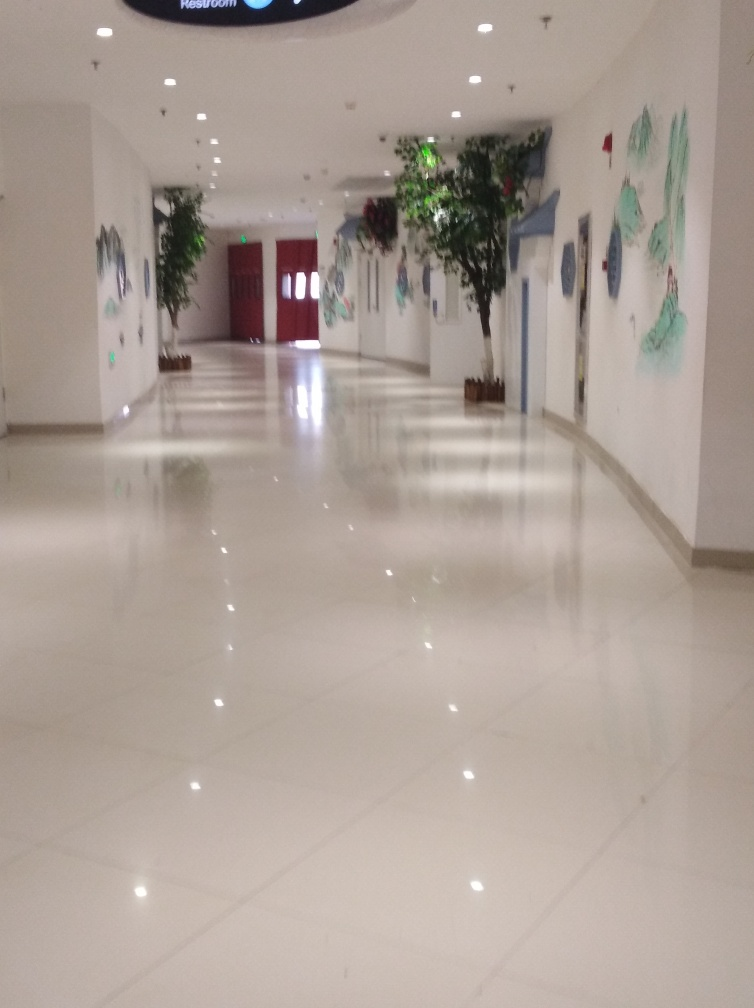Can you comment on the use of lighting in this space? Certainly, the lighting in the space seems thoughtfully designed to create a welcoming ambiance. The ceiling lights provide a soft and even illumination, reflected beautifully on the shiny floor, contributing to the feeling of spaciousness. The strategic placement of lights appears to highlight the wall art without creating harsh shadows, which complements the overall aesthetic of the corridor. 